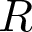<formula> <loc_0><loc_0><loc_500><loc_500>R</formula> 